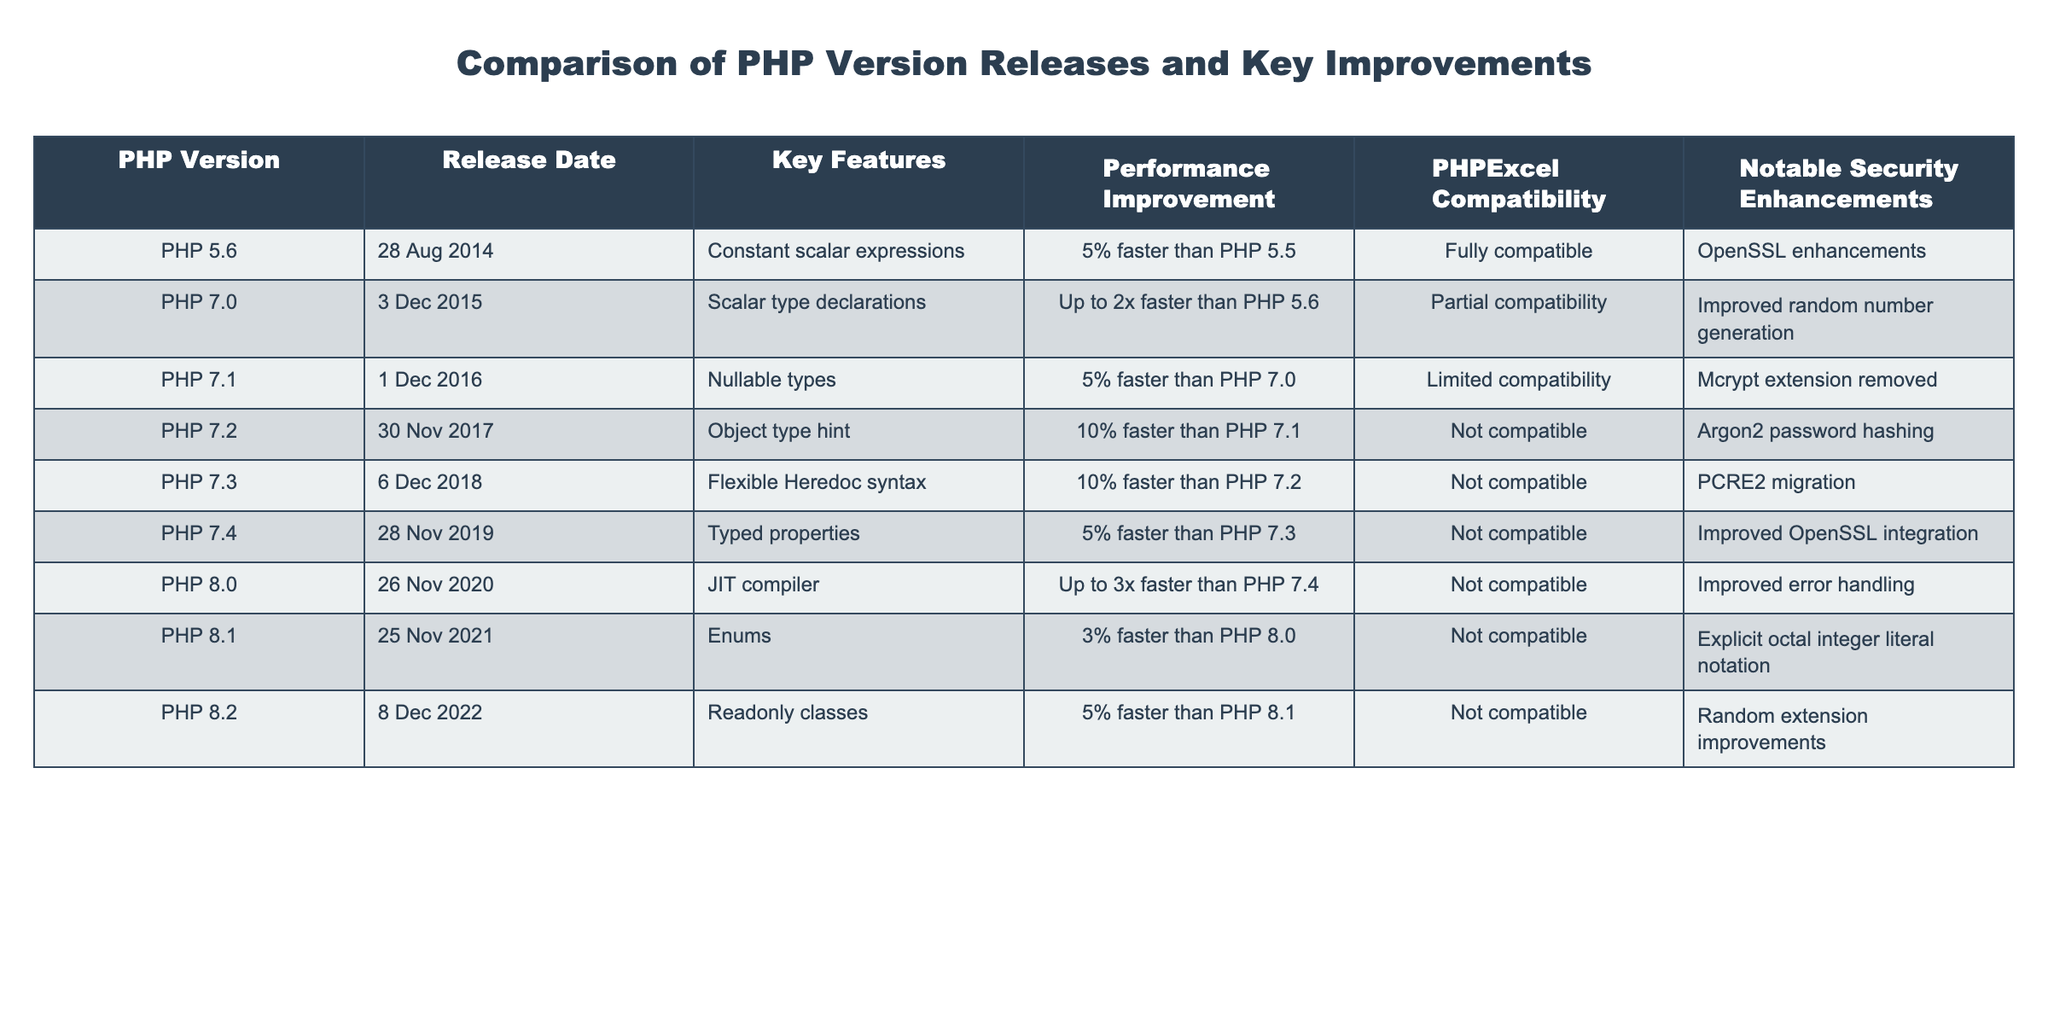What is the release date of PHP 7.2? The release date for PHP 7.2 can be found in the "Release Date" column of the table. According to the data, PHP 7.2 was released on "30 Nov 2017".
Answer: 30 Nov 2017 Which PHP version improved performance by the highest percentage? The performance improvements can be assessed in the "Performance Improvement" column. PHP 8.0 has an improvement labeled as "Up to 3x faster than PHP 7.4", which reflects the highest percentage increase when compared to the other versions.
Answer: PHP 8.0 Is PHP 5.6 compatible with PHPExcel? Looking at the "PHPExcel Compatibility" column, it indicates that PHP 5.6 is "Fully compatible", indicating it can work without issues with PHPExcel.
Answer: Yes What key feature was introduced in PHP 7.1? The "Key Features" column provides details on the features introduced in each version. PHP 7.1 introduced "Nullable types".
Answer: Nullable types How much faster is PHP 7.4 compared to PHP 7.3? To find this, we look at the "Performance Improvement" column. PHP 7.4 is "5% faster than PHP 7.3". Thus, the difference is simply stated as 5%.
Answer: 5% What notable security enhancement was added in PHP 8.2? Referring to the "Notable Security Enhancements" column, PHP 8.2 introduced "Random extension improvements" as its notable security enhancement.
Answer: Random extension improvements Was PHP 7.0 compatible with PHPExcel? Consulting the "PHPExcel Compatibility" column shows that PHP 7.0 is labeled as "Partial compatibility", indicating that it may have some compatibility issues with PHPExcel.
Answer: No Which version had a performance improvement of 10%? We can check the "Performance Improvement" column for various versions. PHP 7.2 and PHP 7.3 both report a 10% increase in performance compared to their predecessors (PHP 7.1 and PHP 7.2, respectively).
Answer: PHP 7.2, PHP 7.3 What is the average performance improvement reported between PHP 7.3 and PHP 8.1? From the "Performance Improvement" column, PHP 7.3 has a 10% improvement over PHP 7.2, and PHP 8.1 has a 3% improvement over PHP 8.0. To find the average: (10 + 3) / 2 = 6.5%.
Answer: 6.5% 